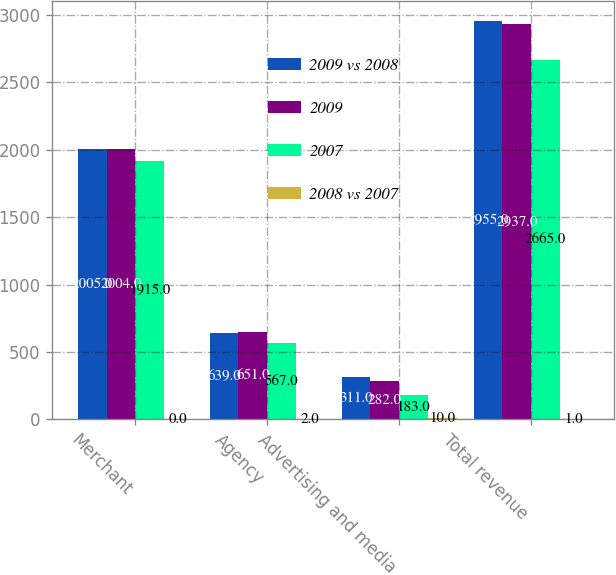Convert chart. <chart><loc_0><loc_0><loc_500><loc_500><stacked_bar_chart><ecel><fcel>Merchant<fcel>Agency<fcel>Advertising and media<fcel>Total revenue<nl><fcel>2009 vs 2008<fcel>2005<fcel>639<fcel>311<fcel>2955<nl><fcel>2009<fcel>2004<fcel>651<fcel>282<fcel>2937<nl><fcel>2007<fcel>1915<fcel>567<fcel>183<fcel>2665<nl><fcel>2008 vs 2007<fcel>0<fcel>2<fcel>10<fcel>1<nl></chart> 